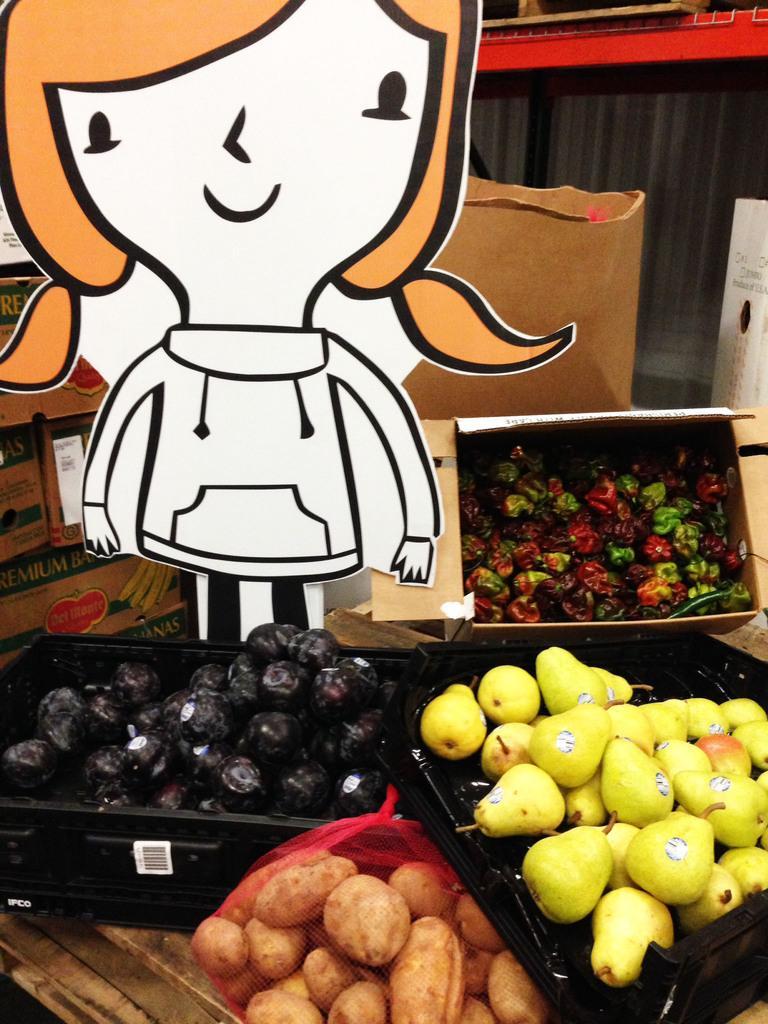Please provide a concise description of this image. In the image I can see some trays in which there are some fruits and also I can see a cartoon to the side. 